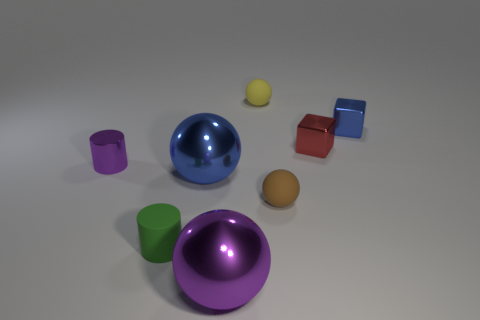How many unique colors are present in the objects displayed in the image? There is a delightful array of five distinct colors represented among the objects in this scene. 